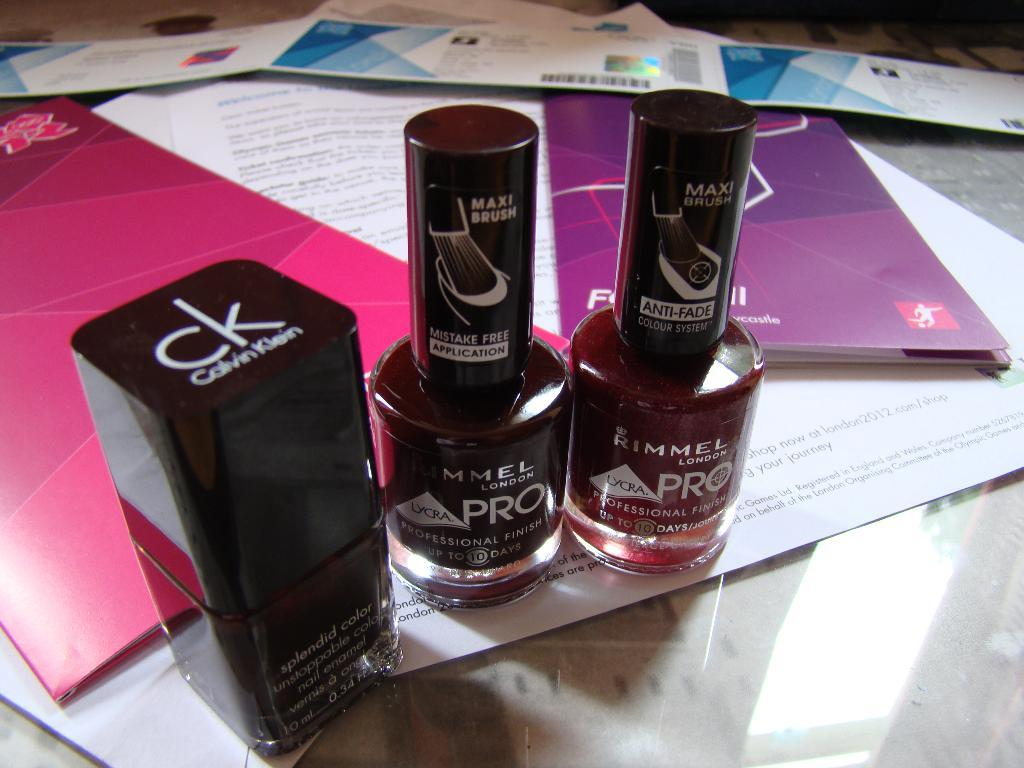<image>
Present a compact description of the photo's key features. Three nail polish jars sit together, the first is from Calvin Klein. 